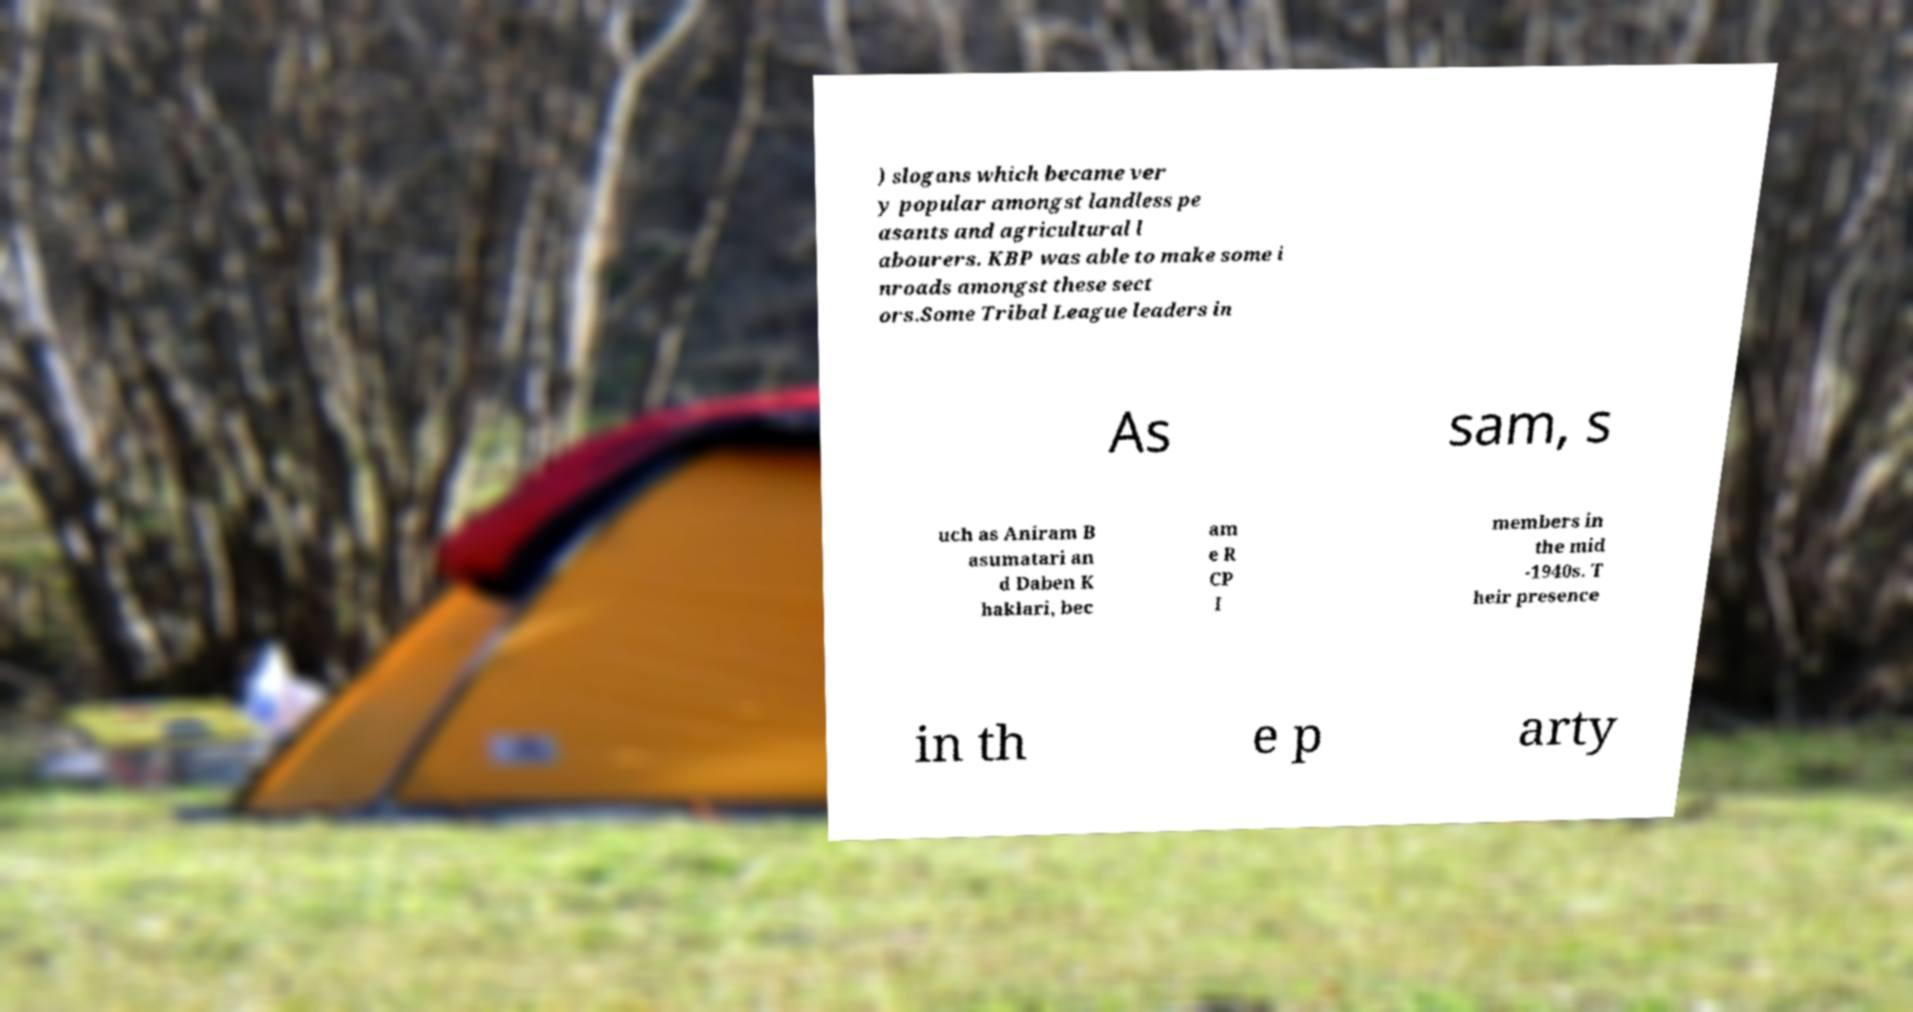Could you assist in decoding the text presented in this image and type it out clearly? ) slogans which became ver y popular amongst landless pe asants and agricultural l abourers. KBP was able to make some i nroads amongst these sect ors.Some Tribal League leaders in As sam, s uch as Aniram B asumatari an d Daben K haklari, bec am e R CP I members in the mid -1940s. T heir presence in th e p arty 